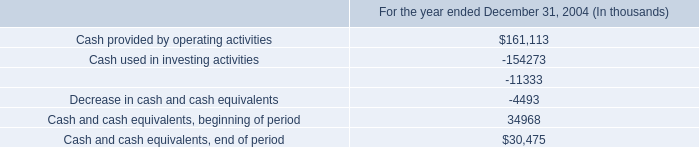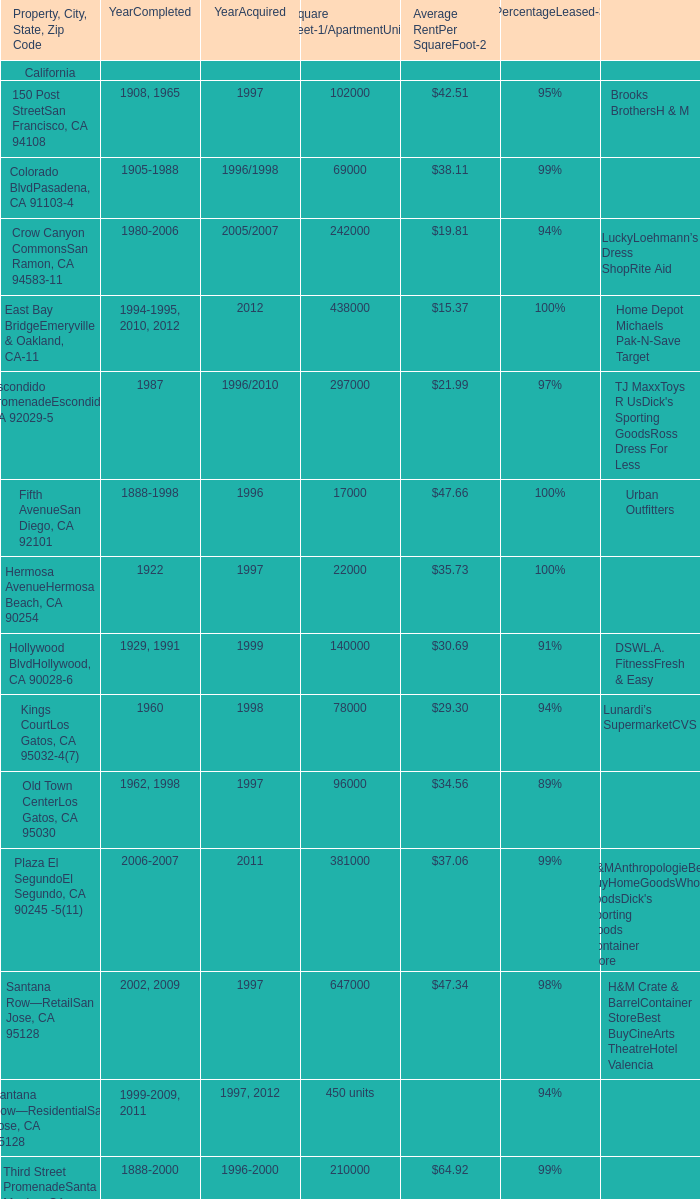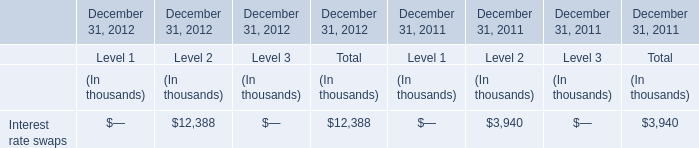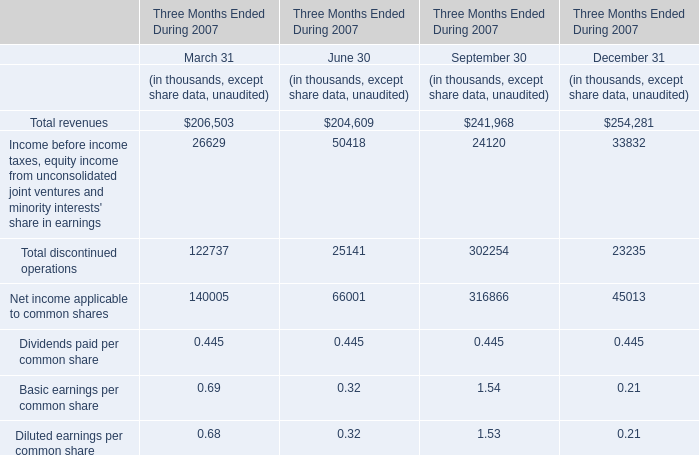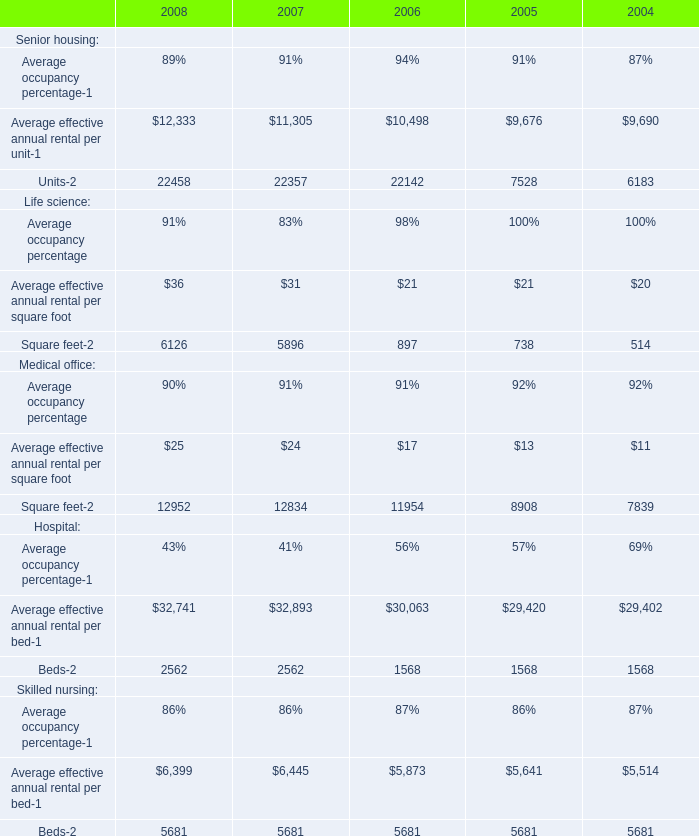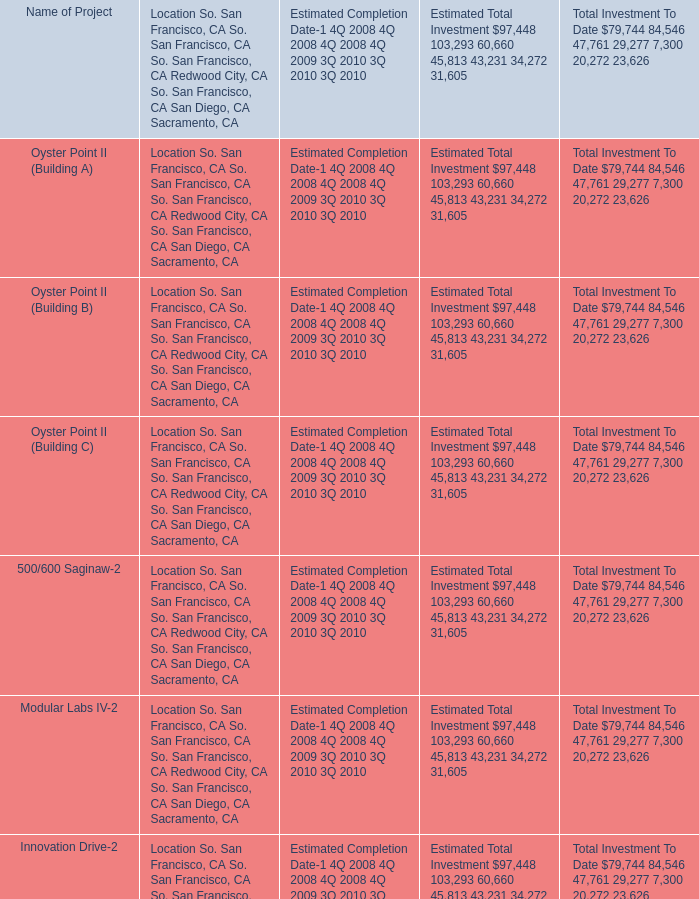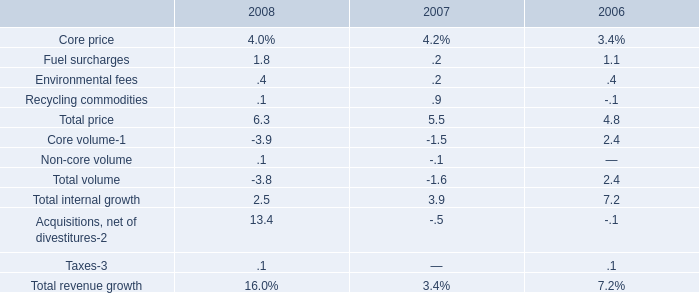what was the average cost of operations from 2006 to 2008 in millions 
Computations: (((2.4 + 2.0) + 1.9) / 3)
Answer: 2.1. 